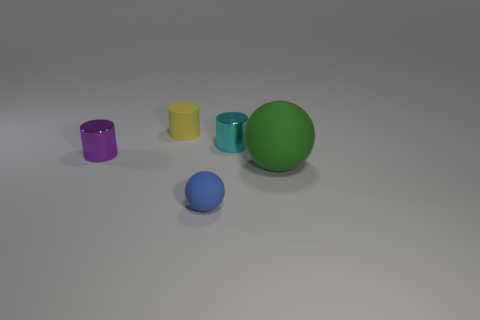There is a purple object that is the same shape as the tiny yellow thing; what is it made of?
Make the answer very short. Metal. Are there any green rubber objects left of the small sphere?
Your answer should be very brief. No. Are the small thing that is on the right side of the blue thing and the tiny blue thing made of the same material?
Ensure brevity in your answer.  No. Are there any large metallic cylinders that have the same color as the small matte sphere?
Offer a terse response. No. The blue thing is what shape?
Your answer should be compact. Sphere. The tiny metal cylinder in front of the tiny metal cylinder that is on the right side of the blue rubber thing is what color?
Your answer should be compact. Purple. There is a shiny object that is on the right side of the small blue ball; what size is it?
Make the answer very short. Small. Is there a purple thing that has the same material as the purple cylinder?
Your answer should be very brief. No. What number of small purple objects have the same shape as the tiny cyan metal object?
Your answer should be compact. 1. The small thing that is behind the tiny metal cylinder that is on the right side of the small cylinder that is to the left of the yellow matte thing is what shape?
Give a very brief answer. Cylinder. 